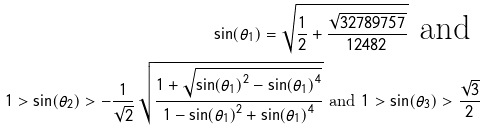Convert formula to latex. <formula><loc_0><loc_0><loc_500><loc_500>\sin ( { { \theta } _ { 1 } } ) = { \sqrt { \frac { 1 } { 2 } + \frac { { \sqrt { 3 2 7 8 9 7 5 7 } } } { 1 2 4 8 2 } } } \text { and } \\ 1 > \sin ( { { \theta } _ { 2 } } ) > - { \frac { 1 } { \sqrt { 2 } } } \, { \sqrt { \frac { 1 + { \sqrt { { \sin ( { { \theta } _ { 1 } } ) } ^ { 2 } - { \sin ( { { \theta } _ { 1 } } ) } ^ { 4 } } } } { 1 - { \sin ( { { \theta } _ { 1 } } ) } ^ { 2 } + { \sin ( { { \theta } _ { 1 } } ) } ^ { 4 } } } } \text { and } 1 > \sin ( { { \theta } _ { 3 } } ) > \frac { { \sqrt { 3 } } } { 2 }</formula> 